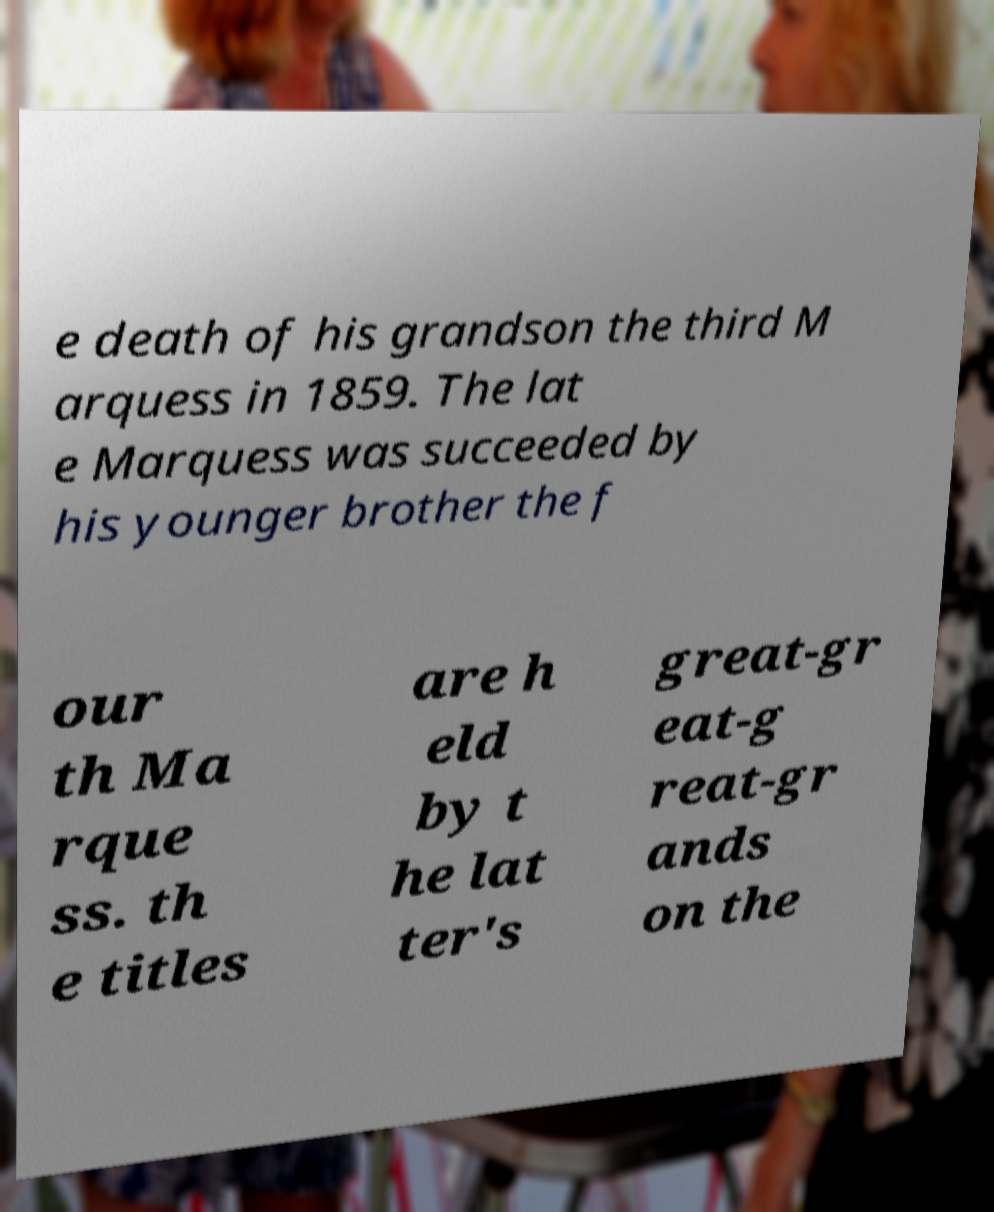Could you extract and type out the text from this image? e death of his grandson the third M arquess in 1859. The lat e Marquess was succeeded by his younger brother the f our th Ma rque ss. th e titles are h eld by t he lat ter's great-gr eat-g reat-gr ands on the 